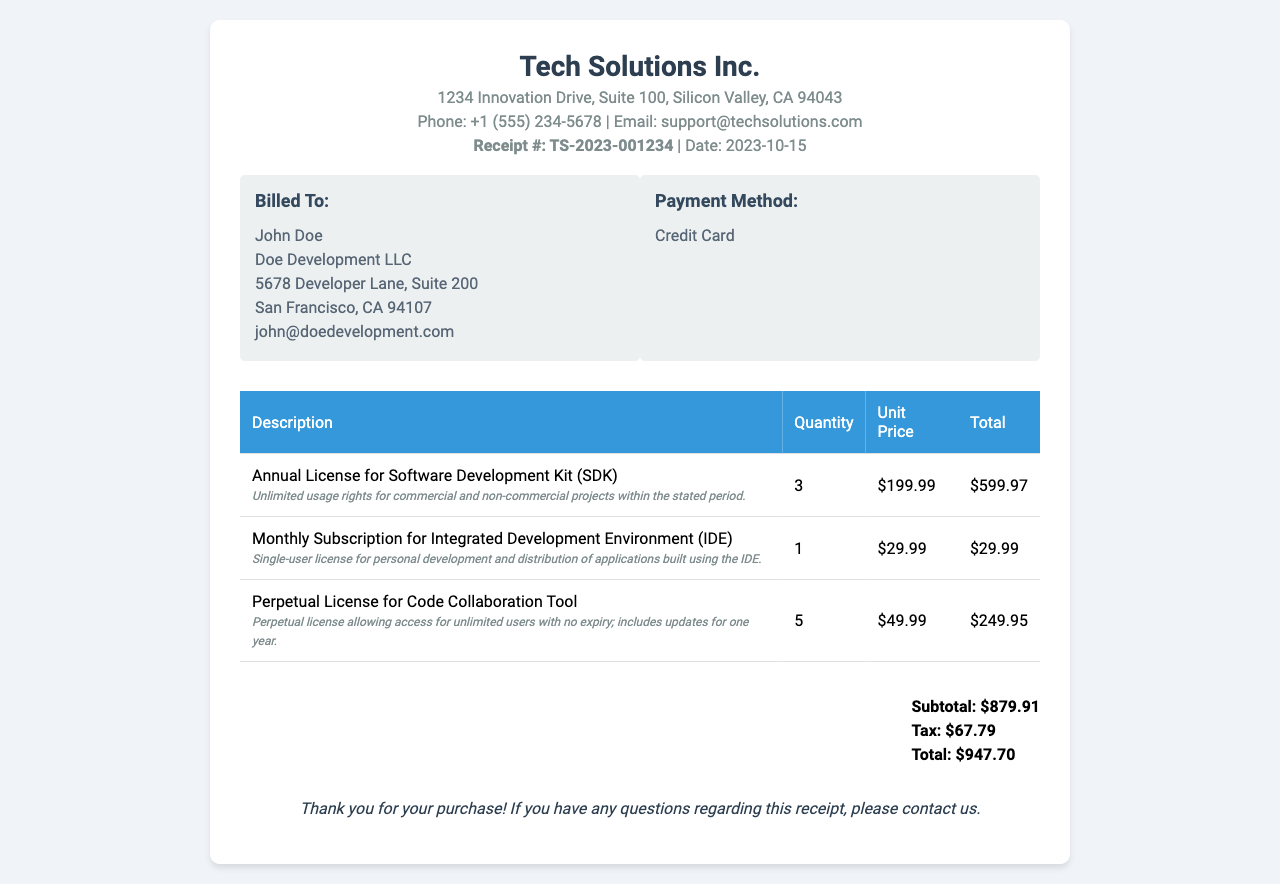What is the receipt number? The receipt number is specified in the header section of the document as TS-2023-001234.
Answer: TS-2023-001234 Who is billed on this receipt? The billing information is in the info box labeled "Billed To," which lists John Doe and Doe Development LLC.
Answer: John Doe What is the total amount due? The total amount is calculated at the bottom of the document, combining subtotal and tax.
Answer: $947.70 How many Annual Licenses for the Software Development Kit were purchased? The quantity of the Annual License for the SDK is found in the table listing the purchased items.
Answer: 3 What is the usage right for the Monthly Subscription of the Integrated Development Environment? The usage right for the IDE is specified beneath the item description in the table.
Answer: Single-user license for personal development and distribution of applications built using the IDE What is the payment method used? The payment method is listed in the info box, indicating how the bill was settled.
Answer: Credit Card What is the tax amount? The tax amount is listed in the total section of the document.
Answer: $67.79 What is the total number of licenses purchased? The total number of licenses can be summed from the quantities of each license type in the table.
Answer: 9 